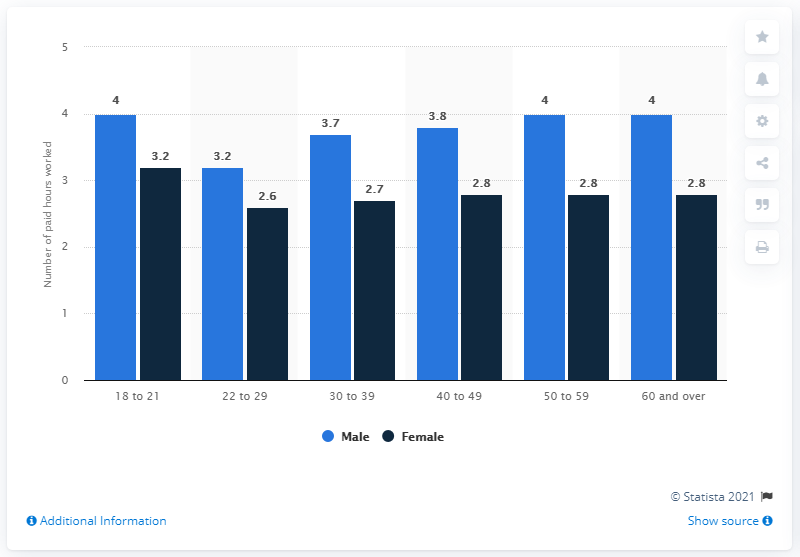Mention a couple of crucial points in this snapshot. The difference between the shortest light blue bar and the tallest dark blue bar is 0, which falls within the range of 0 and 100. The difference between the 18-21 year old male group and the 22-29 year old male group was 0.8. 